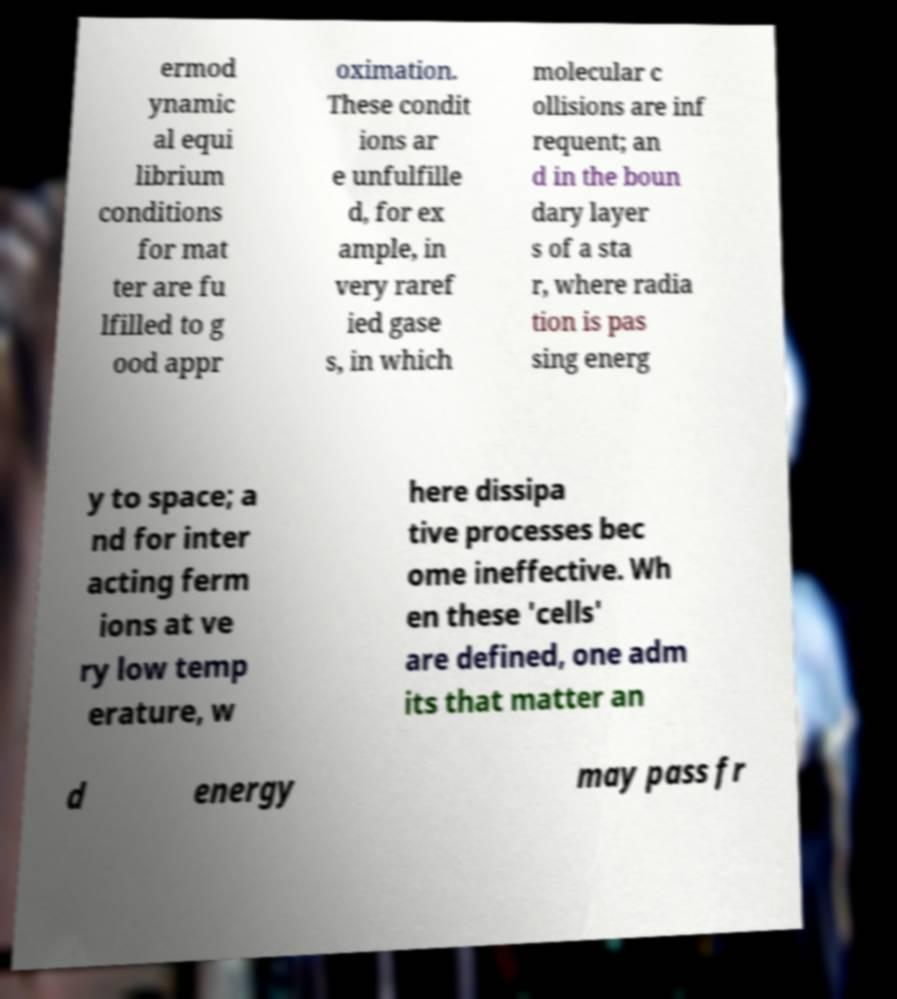Could you extract and type out the text from this image? ermod ynamic al equi librium conditions for mat ter are fu lfilled to g ood appr oximation. These condit ions ar e unfulfille d, for ex ample, in very raref ied gase s, in which molecular c ollisions are inf requent; an d in the boun dary layer s of a sta r, where radia tion is pas sing energ y to space; a nd for inter acting ferm ions at ve ry low temp erature, w here dissipa tive processes bec ome ineffective. Wh en these 'cells' are defined, one adm its that matter an d energy may pass fr 